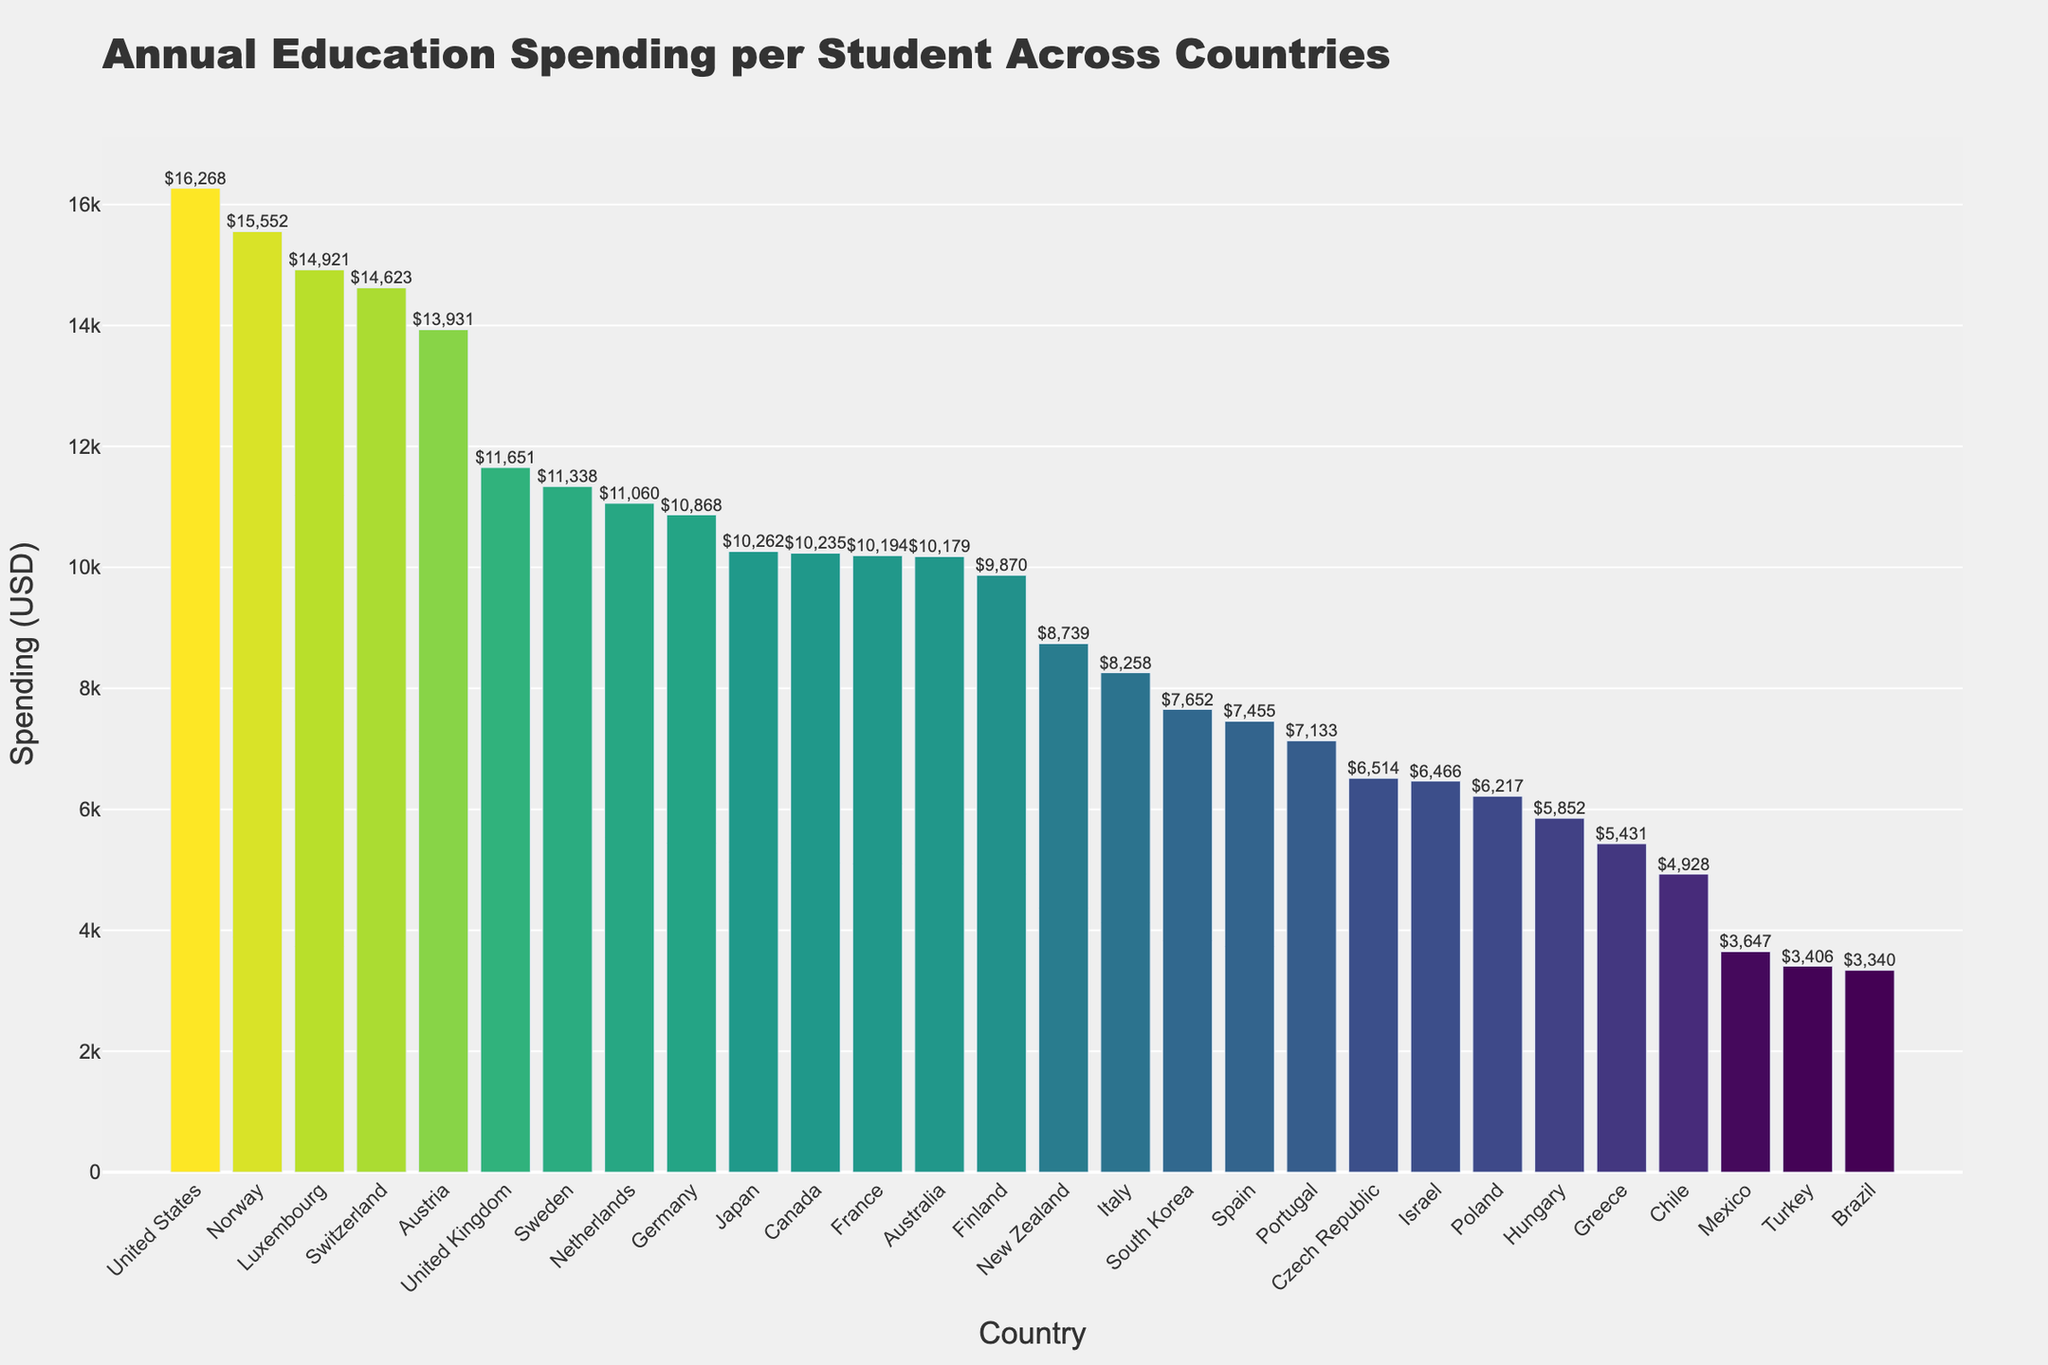Which country has the highest annual education spending per student? The bar chart shows the annual education spending per student for each country. The highest bar corresponds to the United States.
Answer: United States Which country spends more on education per student: Japan or Australia? The bars corresponding to Japan and Australia need to be compared. Japan's bar is slightly higher than Australia's bar.
Answer: Japan What is the difference in annual education spending per student between Luxembourg and Germany? Locate the bars for Luxembourg and Germany: Luxembourg spends $14,921 and Germany spends $10,868. The difference is $14,921 - $10,868.
Answer: $4,053 What is the sum of annual education spending per student for Portugal and Poland? Locate the bars for Portugal and Poland: Portugal spends $7,133 and Poland spends $6,217. The sum is $7,133 + $6,217.
Answer: $13,350 Which country has the lowest annual education spending per student? The bar chart shows the annual education spending per student for each country. The lowest bar corresponds to Brazil.
Answer: Brazil Which three countries have the highest annual education spending per student? Identify the three tallest bars in the chart: The United States, Norway, and Luxembourg have the highest spending per student.
Answer: United States, Norway, Luxembourg Among the countries with spending below $10,000, which country has the highest annual education spending per student? Identify the bars below the $10,000 mark and find the highest among them. Finland, with an annual spending of $9,870, is the highest among those below $10,000.
Answer: Finland Which countries spend more on education per student than the United Kingdom but less than Norway? Identify the bars for countries that lie between the United Kingdom and Norway in height: Austria, Switzerland, Luxembourg are the ones that meet this criterion.
Answer: Austria, Switzerland, Luxembourg 